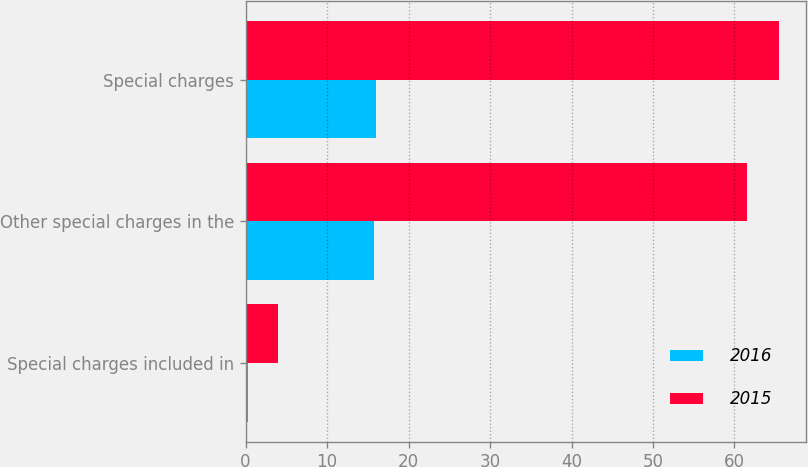Convert chart to OTSL. <chart><loc_0><loc_0><loc_500><loc_500><stacked_bar_chart><ecel><fcel>Special charges included in<fcel>Other special charges in the<fcel>Special charges<nl><fcel>2016<fcel>0.3<fcel>15.7<fcel>16<nl><fcel>2015<fcel>4<fcel>61.5<fcel>65.5<nl></chart> 